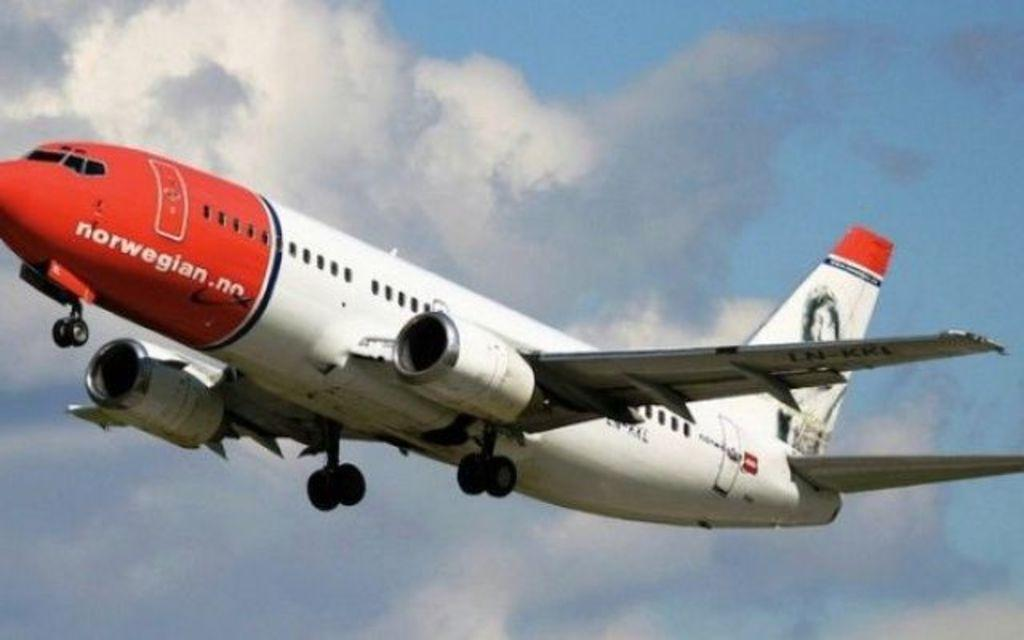<image>
Describe the image concisely. a red and white air plane with a norwegian airline. 